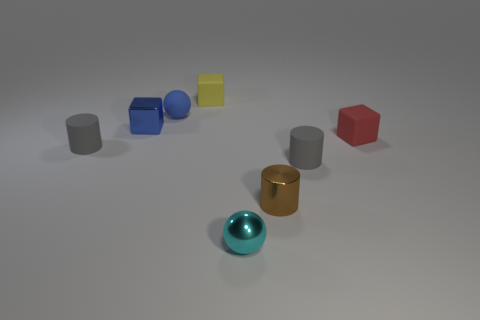Subtract 1 blocks. How many blocks are left? 2 Add 1 large brown cubes. How many objects exist? 9 Subtract all spheres. How many objects are left? 6 Add 3 small cyan cylinders. How many small cyan cylinders exist? 3 Subtract 0 red cylinders. How many objects are left? 8 Subtract all blue blocks. Subtract all small spheres. How many objects are left? 5 Add 1 metallic objects. How many metallic objects are left? 4 